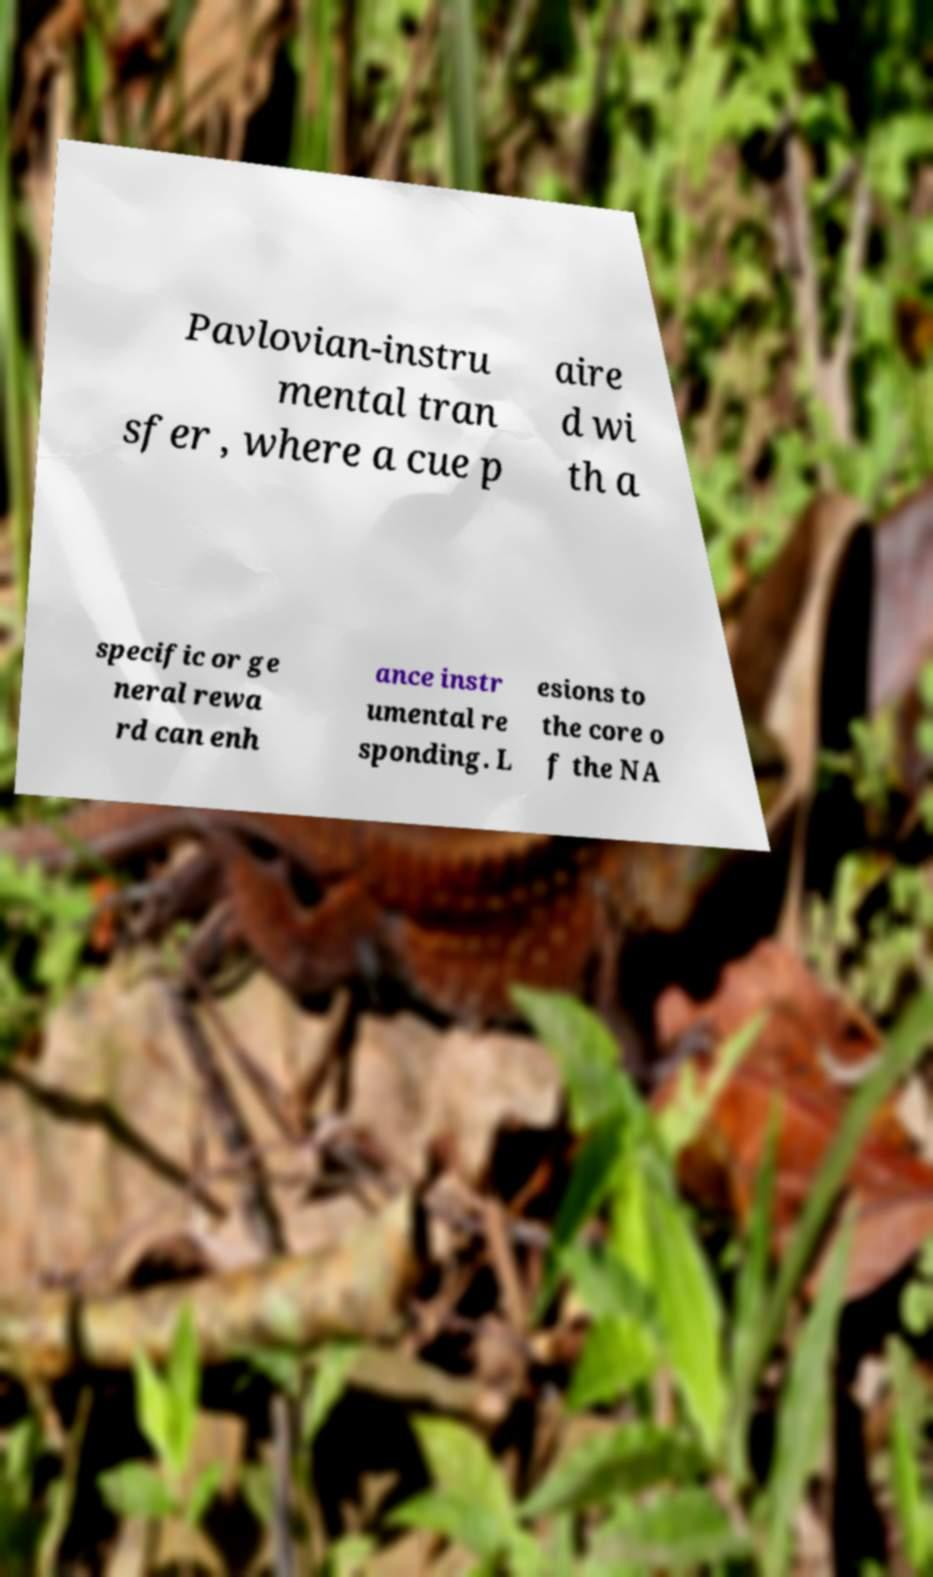Can you read and provide the text displayed in the image?This photo seems to have some interesting text. Can you extract and type it out for me? Pavlovian-instru mental tran sfer , where a cue p aire d wi th a specific or ge neral rewa rd can enh ance instr umental re sponding. L esions to the core o f the NA 